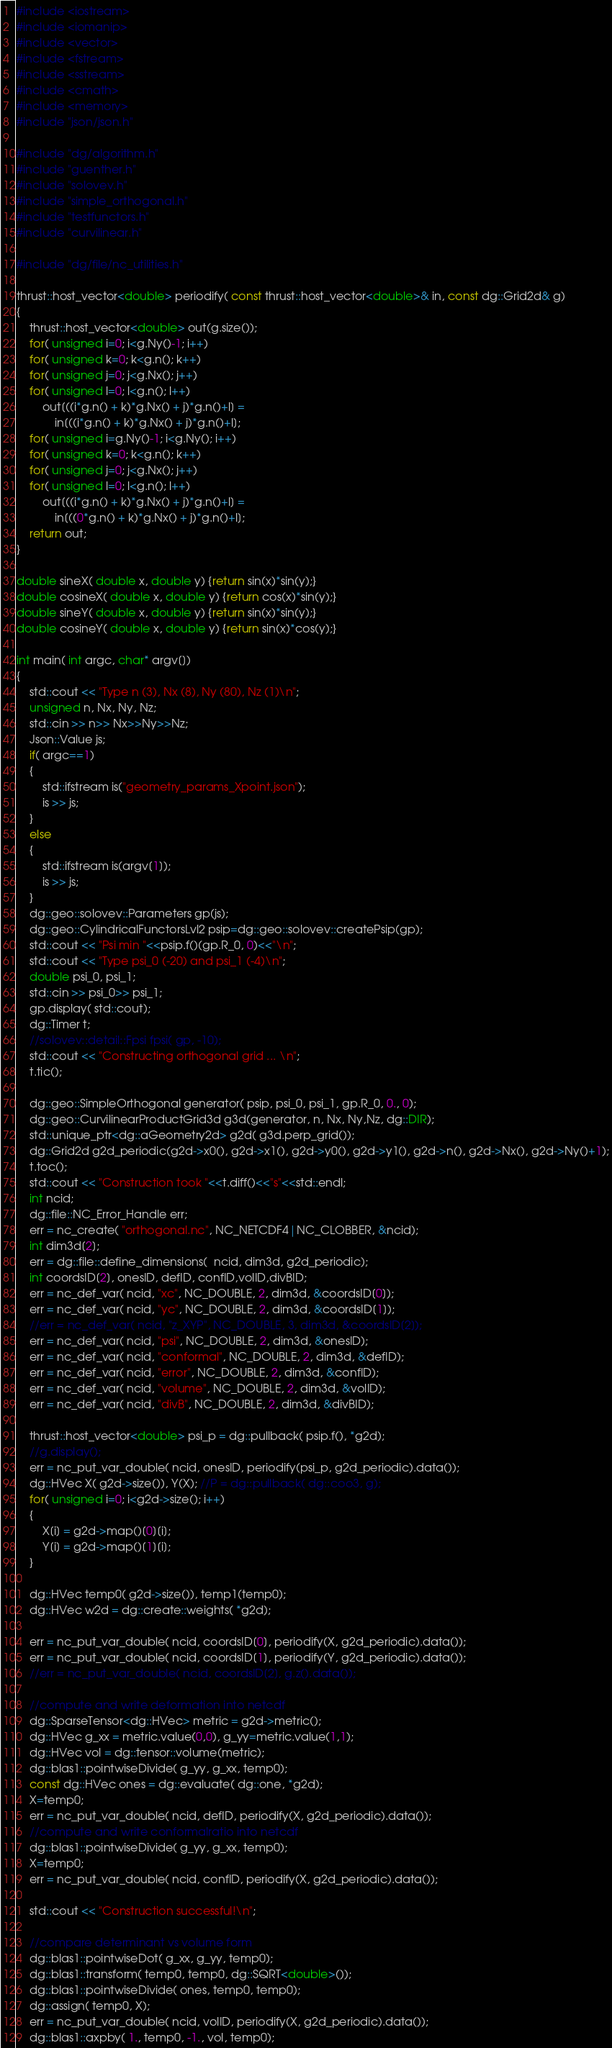Convert code to text. <code><loc_0><loc_0><loc_500><loc_500><_Cuda_>#include <iostream>
#include <iomanip>
#include <vector>
#include <fstream>
#include <sstream>
#include <cmath>
#include <memory>
#include "json/json.h"

#include "dg/algorithm.h"
#include "guenther.h"
#include "solovev.h"
#include "simple_orthogonal.h"
#include "testfunctors.h"
#include "curvilinear.h"

#include "dg/file/nc_utilities.h"

thrust::host_vector<double> periodify( const thrust::host_vector<double>& in, const dg::Grid2d& g)
{
    thrust::host_vector<double> out(g.size());
    for( unsigned i=0; i<g.Ny()-1; i++)
    for( unsigned k=0; k<g.n(); k++)
    for( unsigned j=0; j<g.Nx(); j++)
    for( unsigned l=0; l<g.n(); l++)
        out[((i*g.n() + k)*g.Nx() + j)*g.n()+l] =
            in[((i*g.n() + k)*g.Nx() + j)*g.n()+l];
    for( unsigned i=g.Ny()-1; i<g.Ny(); i++)
    for( unsigned k=0; k<g.n(); k++)
    for( unsigned j=0; j<g.Nx(); j++)
    for( unsigned l=0; l<g.n(); l++)
        out[((i*g.n() + k)*g.Nx() + j)*g.n()+l] =
            in[((0*g.n() + k)*g.Nx() + j)*g.n()+l];
    return out;
}

double sineX( double x, double y) {return sin(x)*sin(y);}
double cosineX( double x, double y) {return cos(x)*sin(y);}
double sineY( double x, double y) {return sin(x)*sin(y);}
double cosineY( double x, double y) {return sin(x)*cos(y);}

int main( int argc, char* argv[])
{
    std::cout << "Type n (3), Nx (8), Ny (80), Nz (1)\n";
    unsigned n, Nx, Ny, Nz;
    std::cin >> n>> Nx>>Ny>>Nz;
    Json::Value js;
    if( argc==1)
    {
        std::ifstream is("geometry_params_Xpoint.json");
        is >> js;
    }
    else
    {
        std::ifstream is(argv[1]);
        is >> js;
    }
    dg::geo::solovev::Parameters gp(js);
    dg::geo::CylindricalFunctorsLvl2 psip=dg::geo::solovev::createPsip(gp);
    std::cout << "Psi min "<<psip.f()(gp.R_0, 0)<<"\n";
    std::cout << "Type psi_0 (-20) and psi_1 (-4)\n";
    double psi_0, psi_1;
    std::cin >> psi_0>> psi_1;
    gp.display( std::cout);
    dg::Timer t;
    //solovev::detail::Fpsi fpsi( gp, -10);
    std::cout << "Constructing orthogonal grid ... \n";
    t.tic();

    dg::geo::SimpleOrthogonal generator( psip, psi_0, psi_1, gp.R_0, 0., 0);
    dg::geo::CurvilinearProductGrid3d g3d(generator, n, Nx, Ny,Nz, dg::DIR);
    std::unique_ptr<dg::aGeometry2d> g2d( g3d.perp_grid());
    dg::Grid2d g2d_periodic(g2d->x0(), g2d->x1(), g2d->y0(), g2d->y1(), g2d->n(), g2d->Nx(), g2d->Ny()+1);
    t.toc();
    std::cout << "Construction took "<<t.diff()<<"s"<<std::endl;
    int ncid;
    dg::file::NC_Error_Handle err;
    err = nc_create( "orthogonal.nc", NC_NETCDF4|NC_CLOBBER, &ncid);
    int dim3d[2];
    err = dg::file::define_dimensions(  ncid, dim3d, g2d_periodic);
    int coordsID[2], onesID, defID, confID,volID,divBID;
    err = nc_def_var( ncid, "xc", NC_DOUBLE, 2, dim3d, &coordsID[0]);
    err = nc_def_var( ncid, "yc", NC_DOUBLE, 2, dim3d, &coordsID[1]);
    //err = nc_def_var( ncid, "z_XYP", NC_DOUBLE, 3, dim3d, &coordsID[2]);
    err = nc_def_var( ncid, "psi", NC_DOUBLE, 2, dim3d, &onesID);
    err = nc_def_var( ncid, "conformal", NC_DOUBLE, 2, dim3d, &defID);
    err = nc_def_var( ncid, "error", NC_DOUBLE, 2, dim3d, &confID);
    err = nc_def_var( ncid, "volume", NC_DOUBLE, 2, dim3d, &volID);
    err = nc_def_var( ncid, "divB", NC_DOUBLE, 2, dim3d, &divBID);

    thrust::host_vector<double> psi_p = dg::pullback( psip.f(), *g2d);
    //g.display();
    err = nc_put_var_double( ncid, onesID, periodify(psi_p, g2d_periodic).data());
    dg::HVec X( g2d->size()), Y(X); //P = dg::pullback( dg::coo3, g);
    for( unsigned i=0; i<g2d->size(); i++)
    {
        X[i] = g2d->map()[0][i];
        Y[i] = g2d->map()[1][i];
    }

    dg::HVec temp0( g2d->size()), temp1(temp0);
    dg::HVec w2d = dg::create::weights( *g2d);

    err = nc_put_var_double( ncid, coordsID[0], periodify(X, g2d_periodic).data());
    err = nc_put_var_double( ncid, coordsID[1], periodify(Y, g2d_periodic).data());
    //err = nc_put_var_double( ncid, coordsID[2], g.z().data());

    //compute and write deformation into netcdf
    dg::SparseTensor<dg::HVec> metric = g2d->metric();
    dg::HVec g_xx = metric.value(0,0), g_yy=metric.value(1,1);
    dg::HVec vol = dg::tensor::volume(metric);
    dg::blas1::pointwiseDivide( g_yy, g_xx, temp0);
    const dg::HVec ones = dg::evaluate( dg::one, *g2d);
    X=temp0;
    err = nc_put_var_double( ncid, defID, periodify(X, g2d_periodic).data());
    //compute and write conformalratio into netcdf
    dg::blas1::pointwiseDivide( g_yy, g_xx, temp0);
    X=temp0;
    err = nc_put_var_double( ncid, confID, periodify(X, g2d_periodic).data());

    std::cout << "Construction successful!\n";

    //compare determinant vs volume form
    dg::blas1::pointwiseDot( g_xx, g_yy, temp0);
    dg::blas1::transform( temp0, temp0, dg::SQRT<double>());
    dg::blas1::pointwiseDivide( ones, temp0, temp0);
    dg::assign( temp0, X);
    err = nc_put_var_double( ncid, volID, periodify(X, g2d_periodic).data());
    dg::blas1::axpby( 1., temp0, -1., vol, temp0);</code> 